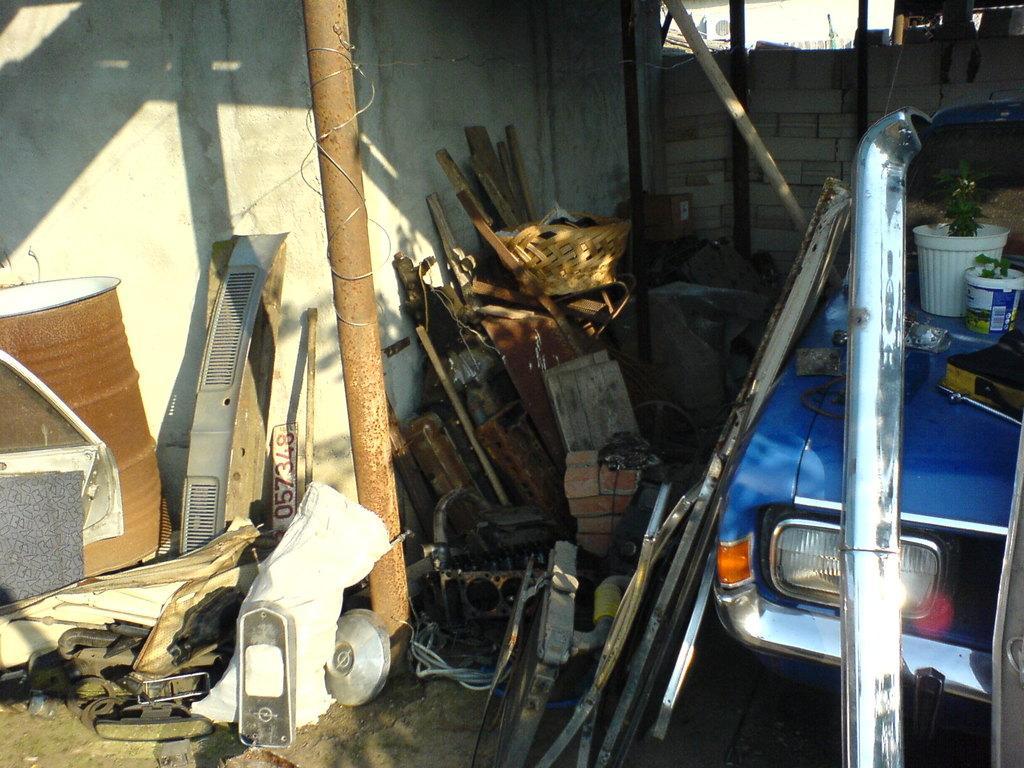How would you summarize this image in a sentence or two? In this picture we can see some iron scrap and drum in the image. Beside there is a blue car. In the background we can see brick wall. 